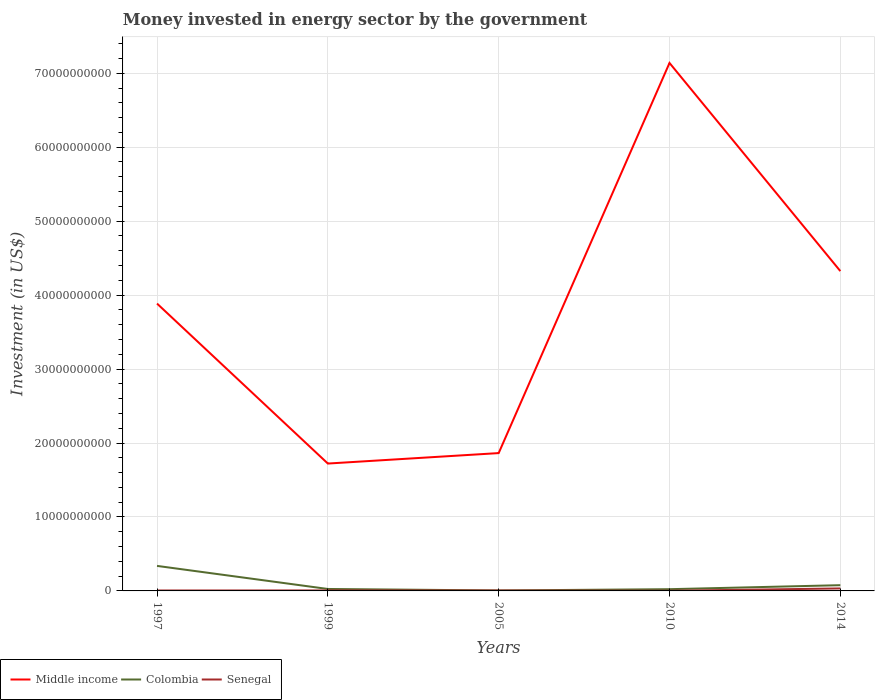How many different coloured lines are there?
Your answer should be compact. 3. Does the line corresponding to Senegal intersect with the line corresponding to Middle income?
Ensure brevity in your answer.  No. Is the number of lines equal to the number of legend labels?
Your answer should be very brief. Yes. Across all years, what is the maximum money spent in energy sector in Middle income?
Give a very brief answer. 1.72e+1. In which year was the money spent in energy sector in Middle income maximum?
Give a very brief answer. 1999. What is the total money spent in energy sector in Middle income in the graph?
Offer a very short reply. -1.41e+09. What is the difference between the highest and the second highest money spent in energy sector in Colombia?
Your answer should be compact. 3.32e+09. What is the difference between two consecutive major ticks on the Y-axis?
Provide a succinct answer. 1.00e+1. Are the values on the major ticks of Y-axis written in scientific E-notation?
Keep it short and to the point. No. Does the graph contain any zero values?
Provide a succinct answer. No. How many legend labels are there?
Your answer should be compact. 3. How are the legend labels stacked?
Your answer should be compact. Horizontal. What is the title of the graph?
Your answer should be very brief. Money invested in energy sector by the government. What is the label or title of the Y-axis?
Your response must be concise. Investment (in US$). What is the Investment (in US$) in Middle income in 1997?
Your answer should be very brief. 3.89e+1. What is the Investment (in US$) of Colombia in 1997?
Give a very brief answer. 3.38e+09. What is the Investment (in US$) of Senegal in 1997?
Your response must be concise. 5.90e+07. What is the Investment (in US$) of Middle income in 1999?
Offer a very short reply. 1.72e+1. What is the Investment (in US$) of Colombia in 1999?
Keep it short and to the point. 2.64e+08. What is the Investment (in US$) in Senegal in 1999?
Give a very brief answer. 6.50e+07. What is the Investment (in US$) of Middle income in 2005?
Keep it short and to the point. 1.86e+1. What is the Investment (in US$) of Colombia in 2005?
Ensure brevity in your answer.  6.17e+07. What is the Investment (in US$) of Senegal in 2005?
Offer a very short reply. 5.29e+07. What is the Investment (in US$) of Middle income in 2010?
Provide a succinct answer. 7.14e+1. What is the Investment (in US$) in Colombia in 2010?
Provide a short and direct response. 2.35e+08. What is the Investment (in US$) in Senegal in 2010?
Your response must be concise. 2.20e+07. What is the Investment (in US$) in Middle income in 2014?
Ensure brevity in your answer.  4.32e+1. What is the Investment (in US$) in Colombia in 2014?
Give a very brief answer. 7.75e+08. What is the Investment (in US$) in Senegal in 2014?
Offer a very short reply. 3.36e+08. Across all years, what is the maximum Investment (in US$) of Middle income?
Provide a short and direct response. 7.14e+1. Across all years, what is the maximum Investment (in US$) of Colombia?
Provide a short and direct response. 3.38e+09. Across all years, what is the maximum Investment (in US$) in Senegal?
Keep it short and to the point. 3.36e+08. Across all years, what is the minimum Investment (in US$) in Middle income?
Provide a succinct answer. 1.72e+1. Across all years, what is the minimum Investment (in US$) of Colombia?
Make the answer very short. 6.17e+07. Across all years, what is the minimum Investment (in US$) in Senegal?
Offer a terse response. 2.20e+07. What is the total Investment (in US$) of Middle income in the graph?
Your answer should be compact. 1.89e+11. What is the total Investment (in US$) of Colombia in the graph?
Keep it short and to the point. 4.72e+09. What is the total Investment (in US$) in Senegal in the graph?
Make the answer very short. 5.35e+08. What is the difference between the Investment (in US$) in Middle income in 1997 and that in 1999?
Give a very brief answer. 2.16e+1. What is the difference between the Investment (in US$) in Colombia in 1997 and that in 1999?
Make the answer very short. 3.12e+09. What is the difference between the Investment (in US$) of Senegal in 1997 and that in 1999?
Make the answer very short. -6.00e+06. What is the difference between the Investment (in US$) in Middle income in 1997 and that in 2005?
Make the answer very short. 2.02e+1. What is the difference between the Investment (in US$) in Colombia in 1997 and that in 2005?
Offer a very short reply. 3.32e+09. What is the difference between the Investment (in US$) in Senegal in 1997 and that in 2005?
Give a very brief answer. 6.09e+06. What is the difference between the Investment (in US$) of Middle income in 1997 and that in 2010?
Ensure brevity in your answer.  -3.25e+1. What is the difference between the Investment (in US$) of Colombia in 1997 and that in 2010?
Provide a short and direct response. 3.15e+09. What is the difference between the Investment (in US$) in Senegal in 1997 and that in 2010?
Your answer should be compact. 3.70e+07. What is the difference between the Investment (in US$) in Middle income in 1997 and that in 2014?
Make the answer very short. -4.39e+09. What is the difference between the Investment (in US$) of Colombia in 1997 and that in 2014?
Your answer should be compact. 2.61e+09. What is the difference between the Investment (in US$) in Senegal in 1997 and that in 2014?
Your answer should be very brief. -2.77e+08. What is the difference between the Investment (in US$) in Middle income in 1999 and that in 2005?
Your answer should be compact. -1.41e+09. What is the difference between the Investment (in US$) of Colombia in 1999 and that in 2005?
Your answer should be very brief. 2.02e+08. What is the difference between the Investment (in US$) in Senegal in 1999 and that in 2005?
Keep it short and to the point. 1.21e+07. What is the difference between the Investment (in US$) in Middle income in 1999 and that in 2010?
Keep it short and to the point. -5.42e+1. What is the difference between the Investment (in US$) of Colombia in 1999 and that in 2010?
Offer a very short reply. 2.86e+07. What is the difference between the Investment (in US$) in Senegal in 1999 and that in 2010?
Give a very brief answer. 4.30e+07. What is the difference between the Investment (in US$) in Middle income in 1999 and that in 2014?
Give a very brief answer. -2.60e+1. What is the difference between the Investment (in US$) in Colombia in 1999 and that in 2014?
Your answer should be compact. -5.11e+08. What is the difference between the Investment (in US$) of Senegal in 1999 and that in 2014?
Offer a terse response. -2.71e+08. What is the difference between the Investment (in US$) of Middle income in 2005 and that in 2010?
Provide a succinct answer. -5.27e+1. What is the difference between the Investment (in US$) of Colombia in 2005 and that in 2010?
Your answer should be compact. -1.73e+08. What is the difference between the Investment (in US$) of Senegal in 2005 and that in 2010?
Provide a succinct answer. 3.09e+07. What is the difference between the Investment (in US$) in Middle income in 2005 and that in 2014?
Provide a succinct answer. -2.46e+1. What is the difference between the Investment (in US$) in Colombia in 2005 and that in 2014?
Offer a very short reply. -7.13e+08. What is the difference between the Investment (in US$) in Senegal in 2005 and that in 2014?
Give a very brief answer. -2.83e+08. What is the difference between the Investment (in US$) of Middle income in 2010 and that in 2014?
Keep it short and to the point. 2.81e+1. What is the difference between the Investment (in US$) in Colombia in 2010 and that in 2014?
Your answer should be very brief. -5.40e+08. What is the difference between the Investment (in US$) of Senegal in 2010 and that in 2014?
Keep it short and to the point. -3.14e+08. What is the difference between the Investment (in US$) of Middle income in 1997 and the Investment (in US$) of Colombia in 1999?
Provide a short and direct response. 3.86e+1. What is the difference between the Investment (in US$) of Middle income in 1997 and the Investment (in US$) of Senegal in 1999?
Provide a succinct answer. 3.88e+1. What is the difference between the Investment (in US$) in Colombia in 1997 and the Investment (in US$) in Senegal in 1999?
Your response must be concise. 3.32e+09. What is the difference between the Investment (in US$) in Middle income in 1997 and the Investment (in US$) in Colombia in 2005?
Provide a short and direct response. 3.88e+1. What is the difference between the Investment (in US$) of Middle income in 1997 and the Investment (in US$) of Senegal in 2005?
Offer a very short reply. 3.88e+1. What is the difference between the Investment (in US$) of Colombia in 1997 and the Investment (in US$) of Senegal in 2005?
Ensure brevity in your answer.  3.33e+09. What is the difference between the Investment (in US$) in Middle income in 1997 and the Investment (in US$) in Colombia in 2010?
Offer a terse response. 3.86e+1. What is the difference between the Investment (in US$) of Middle income in 1997 and the Investment (in US$) of Senegal in 2010?
Offer a very short reply. 3.88e+1. What is the difference between the Investment (in US$) in Colombia in 1997 and the Investment (in US$) in Senegal in 2010?
Your answer should be very brief. 3.36e+09. What is the difference between the Investment (in US$) of Middle income in 1997 and the Investment (in US$) of Colombia in 2014?
Your response must be concise. 3.81e+1. What is the difference between the Investment (in US$) in Middle income in 1997 and the Investment (in US$) in Senegal in 2014?
Keep it short and to the point. 3.85e+1. What is the difference between the Investment (in US$) of Colombia in 1997 and the Investment (in US$) of Senegal in 2014?
Your answer should be very brief. 3.05e+09. What is the difference between the Investment (in US$) of Middle income in 1999 and the Investment (in US$) of Colombia in 2005?
Keep it short and to the point. 1.72e+1. What is the difference between the Investment (in US$) of Middle income in 1999 and the Investment (in US$) of Senegal in 2005?
Your answer should be very brief. 1.72e+1. What is the difference between the Investment (in US$) of Colombia in 1999 and the Investment (in US$) of Senegal in 2005?
Make the answer very short. 2.11e+08. What is the difference between the Investment (in US$) in Middle income in 1999 and the Investment (in US$) in Colombia in 2010?
Offer a very short reply. 1.70e+1. What is the difference between the Investment (in US$) of Middle income in 1999 and the Investment (in US$) of Senegal in 2010?
Your answer should be very brief. 1.72e+1. What is the difference between the Investment (in US$) in Colombia in 1999 and the Investment (in US$) in Senegal in 2010?
Your answer should be compact. 2.42e+08. What is the difference between the Investment (in US$) of Middle income in 1999 and the Investment (in US$) of Colombia in 2014?
Make the answer very short. 1.64e+1. What is the difference between the Investment (in US$) in Middle income in 1999 and the Investment (in US$) in Senegal in 2014?
Give a very brief answer. 1.69e+1. What is the difference between the Investment (in US$) in Colombia in 1999 and the Investment (in US$) in Senegal in 2014?
Your response must be concise. -7.24e+07. What is the difference between the Investment (in US$) in Middle income in 2005 and the Investment (in US$) in Colombia in 2010?
Offer a very short reply. 1.84e+1. What is the difference between the Investment (in US$) in Middle income in 2005 and the Investment (in US$) in Senegal in 2010?
Keep it short and to the point. 1.86e+1. What is the difference between the Investment (in US$) in Colombia in 2005 and the Investment (in US$) in Senegal in 2010?
Your answer should be very brief. 3.97e+07. What is the difference between the Investment (in US$) in Middle income in 2005 and the Investment (in US$) in Colombia in 2014?
Offer a terse response. 1.79e+1. What is the difference between the Investment (in US$) in Middle income in 2005 and the Investment (in US$) in Senegal in 2014?
Offer a terse response. 1.83e+1. What is the difference between the Investment (in US$) in Colombia in 2005 and the Investment (in US$) in Senegal in 2014?
Your answer should be compact. -2.74e+08. What is the difference between the Investment (in US$) of Middle income in 2010 and the Investment (in US$) of Colombia in 2014?
Your answer should be compact. 7.06e+1. What is the difference between the Investment (in US$) of Middle income in 2010 and the Investment (in US$) of Senegal in 2014?
Keep it short and to the point. 7.10e+1. What is the difference between the Investment (in US$) in Colombia in 2010 and the Investment (in US$) in Senegal in 2014?
Give a very brief answer. -1.01e+08. What is the average Investment (in US$) of Middle income per year?
Your answer should be very brief. 3.79e+1. What is the average Investment (in US$) of Colombia per year?
Provide a short and direct response. 9.44e+08. What is the average Investment (in US$) in Senegal per year?
Provide a short and direct response. 1.07e+08. In the year 1997, what is the difference between the Investment (in US$) in Middle income and Investment (in US$) in Colombia?
Keep it short and to the point. 3.55e+1. In the year 1997, what is the difference between the Investment (in US$) of Middle income and Investment (in US$) of Senegal?
Offer a very short reply. 3.88e+1. In the year 1997, what is the difference between the Investment (in US$) in Colombia and Investment (in US$) in Senegal?
Provide a succinct answer. 3.32e+09. In the year 1999, what is the difference between the Investment (in US$) in Middle income and Investment (in US$) in Colombia?
Ensure brevity in your answer.  1.70e+1. In the year 1999, what is the difference between the Investment (in US$) of Middle income and Investment (in US$) of Senegal?
Give a very brief answer. 1.72e+1. In the year 1999, what is the difference between the Investment (in US$) in Colombia and Investment (in US$) in Senegal?
Your answer should be very brief. 1.99e+08. In the year 2005, what is the difference between the Investment (in US$) in Middle income and Investment (in US$) in Colombia?
Provide a succinct answer. 1.86e+1. In the year 2005, what is the difference between the Investment (in US$) of Middle income and Investment (in US$) of Senegal?
Your response must be concise. 1.86e+1. In the year 2005, what is the difference between the Investment (in US$) in Colombia and Investment (in US$) in Senegal?
Provide a short and direct response. 8.79e+06. In the year 2010, what is the difference between the Investment (in US$) in Middle income and Investment (in US$) in Colombia?
Offer a very short reply. 7.12e+1. In the year 2010, what is the difference between the Investment (in US$) of Middle income and Investment (in US$) of Senegal?
Your response must be concise. 7.14e+1. In the year 2010, what is the difference between the Investment (in US$) in Colombia and Investment (in US$) in Senegal?
Make the answer very short. 2.13e+08. In the year 2014, what is the difference between the Investment (in US$) in Middle income and Investment (in US$) in Colombia?
Give a very brief answer. 4.25e+1. In the year 2014, what is the difference between the Investment (in US$) in Middle income and Investment (in US$) in Senegal?
Make the answer very short. 4.29e+1. In the year 2014, what is the difference between the Investment (in US$) of Colombia and Investment (in US$) of Senegal?
Provide a succinct answer. 4.39e+08. What is the ratio of the Investment (in US$) in Middle income in 1997 to that in 1999?
Your response must be concise. 2.26. What is the ratio of the Investment (in US$) of Colombia in 1997 to that in 1999?
Your answer should be compact. 12.83. What is the ratio of the Investment (in US$) of Senegal in 1997 to that in 1999?
Give a very brief answer. 0.91. What is the ratio of the Investment (in US$) of Middle income in 1997 to that in 2005?
Make the answer very short. 2.08. What is the ratio of the Investment (in US$) of Colombia in 1997 to that in 2005?
Your answer should be compact. 54.83. What is the ratio of the Investment (in US$) in Senegal in 1997 to that in 2005?
Your answer should be compact. 1.12. What is the ratio of the Investment (in US$) of Middle income in 1997 to that in 2010?
Ensure brevity in your answer.  0.54. What is the ratio of the Investment (in US$) of Colombia in 1997 to that in 2010?
Provide a succinct answer. 14.39. What is the ratio of the Investment (in US$) of Senegal in 1997 to that in 2010?
Provide a short and direct response. 2.68. What is the ratio of the Investment (in US$) in Middle income in 1997 to that in 2014?
Offer a very short reply. 0.9. What is the ratio of the Investment (in US$) in Colombia in 1997 to that in 2014?
Your response must be concise. 4.37. What is the ratio of the Investment (in US$) of Senegal in 1997 to that in 2014?
Offer a terse response. 0.18. What is the ratio of the Investment (in US$) of Middle income in 1999 to that in 2005?
Make the answer very short. 0.92. What is the ratio of the Investment (in US$) of Colombia in 1999 to that in 2005?
Provide a short and direct response. 4.27. What is the ratio of the Investment (in US$) of Senegal in 1999 to that in 2005?
Keep it short and to the point. 1.23. What is the ratio of the Investment (in US$) in Middle income in 1999 to that in 2010?
Provide a short and direct response. 0.24. What is the ratio of the Investment (in US$) of Colombia in 1999 to that in 2010?
Your response must be concise. 1.12. What is the ratio of the Investment (in US$) of Senegal in 1999 to that in 2010?
Your answer should be very brief. 2.95. What is the ratio of the Investment (in US$) of Middle income in 1999 to that in 2014?
Provide a succinct answer. 0.4. What is the ratio of the Investment (in US$) in Colombia in 1999 to that in 2014?
Offer a very short reply. 0.34. What is the ratio of the Investment (in US$) in Senegal in 1999 to that in 2014?
Keep it short and to the point. 0.19. What is the ratio of the Investment (in US$) of Middle income in 2005 to that in 2010?
Your answer should be very brief. 0.26. What is the ratio of the Investment (in US$) in Colombia in 2005 to that in 2010?
Make the answer very short. 0.26. What is the ratio of the Investment (in US$) of Senegal in 2005 to that in 2010?
Provide a succinct answer. 2.4. What is the ratio of the Investment (in US$) in Middle income in 2005 to that in 2014?
Provide a succinct answer. 0.43. What is the ratio of the Investment (in US$) of Colombia in 2005 to that in 2014?
Provide a succinct answer. 0.08. What is the ratio of the Investment (in US$) in Senegal in 2005 to that in 2014?
Your answer should be very brief. 0.16. What is the ratio of the Investment (in US$) in Middle income in 2010 to that in 2014?
Your answer should be very brief. 1.65. What is the ratio of the Investment (in US$) in Colombia in 2010 to that in 2014?
Your answer should be very brief. 0.3. What is the ratio of the Investment (in US$) in Senegal in 2010 to that in 2014?
Your response must be concise. 0.07. What is the difference between the highest and the second highest Investment (in US$) in Middle income?
Your answer should be compact. 2.81e+1. What is the difference between the highest and the second highest Investment (in US$) of Colombia?
Your response must be concise. 2.61e+09. What is the difference between the highest and the second highest Investment (in US$) of Senegal?
Make the answer very short. 2.71e+08. What is the difference between the highest and the lowest Investment (in US$) in Middle income?
Ensure brevity in your answer.  5.42e+1. What is the difference between the highest and the lowest Investment (in US$) of Colombia?
Keep it short and to the point. 3.32e+09. What is the difference between the highest and the lowest Investment (in US$) of Senegal?
Provide a short and direct response. 3.14e+08. 